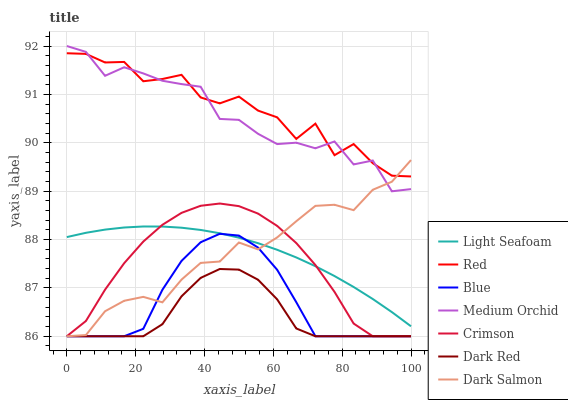Does Dark Red have the minimum area under the curve?
Answer yes or no. Yes. Does Red have the maximum area under the curve?
Answer yes or no. Yes. Does Medium Orchid have the minimum area under the curve?
Answer yes or no. No. Does Medium Orchid have the maximum area under the curve?
Answer yes or no. No. Is Light Seafoam the smoothest?
Answer yes or no. Yes. Is Red the roughest?
Answer yes or no. Yes. Is Dark Red the smoothest?
Answer yes or no. No. Is Dark Red the roughest?
Answer yes or no. No. Does Blue have the lowest value?
Answer yes or no. Yes. Does Medium Orchid have the lowest value?
Answer yes or no. No. Does Medium Orchid have the highest value?
Answer yes or no. Yes. Does Dark Red have the highest value?
Answer yes or no. No. Is Dark Red less than Light Seafoam?
Answer yes or no. Yes. Is Red greater than Light Seafoam?
Answer yes or no. Yes. Does Blue intersect Dark Red?
Answer yes or no. Yes. Is Blue less than Dark Red?
Answer yes or no. No. Is Blue greater than Dark Red?
Answer yes or no. No. Does Dark Red intersect Light Seafoam?
Answer yes or no. No. 